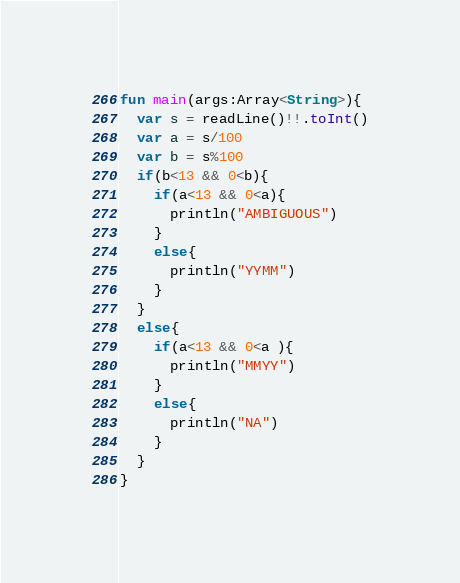<code> <loc_0><loc_0><loc_500><loc_500><_Kotlin_>fun main(args:Array<String>){
  var s = readLine()!!.toInt()
  var a = s/100
  var b = s%100
  if(b<13 && 0<b){
    if(a<13 && 0<a){
      println("AMBIGUOUS")
    }
    else{
      println("YYMM")
    }
  }
  else{
    if(a<13 && 0<a ){
      println("MMYY")
    }
    else{
      println("NA")
    }
  }
}</code> 